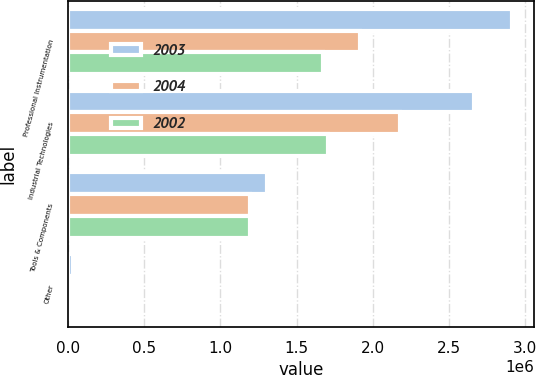<chart> <loc_0><loc_0><loc_500><loc_500><stacked_bar_chart><ecel><fcel>Professional Instrumentation<fcel>Industrial Technologies<fcel>Tools & Components<fcel>Other<nl><fcel>2003<fcel>2.91569e+06<fcel>2.66735e+06<fcel>1.30626e+06<fcel>30644<nl><fcel>2004<fcel>1.91601e+06<fcel>2.18067e+06<fcel>1.19719e+06<fcel>24669<nl><fcel>2002<fcel>1.67609e+06<fcel>1.70907e+06<fcel>1.19208e+06<fcel>20694<nl></chart> 